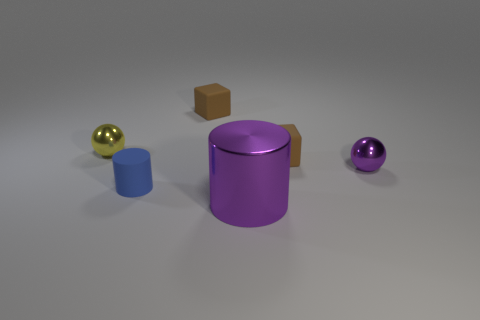Add 2 big purple shiny balls. How many objects exist? 8 Subtract all spheres. How many objects are left? 4 Subtract all purple cylinders. How many cylinders are left? 1 Subtract 1 spheres. How many spheres are left? 1 Add 5 purple metallic cylinders. How many purple metallic cylinders are left? 6 Add 3 balls. How many balls exist? 5 Subtract 0 yellow cubes. How many objects are left? 6 Subtract all gray cylinders. Subtract all cyan blocks. How many cylinders are left? 2 Subtract all big green things. Subtract all rubber objects. How many objects are left? 3 